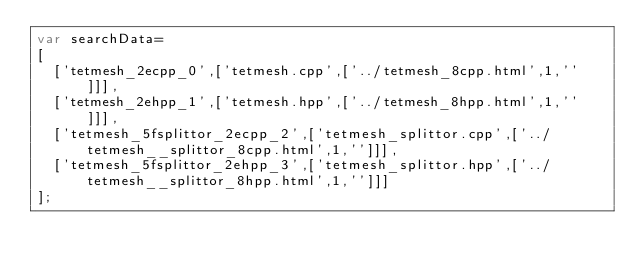Convert code to text. <code><loc_0><loc_0><loc_500><loc_500><_JavaScript_>var searchData=
[
  ['tetmesh_2ecpp_0',['tetmesh.cpp',['../tetmesh_8cpp.html',1,'']]],
  ['tetmesh_2ehpp_1',['tetmesh.hpp',['../tetmesh_8hpp.html',1,'']]],
  ['tetmesh_5fsplittor_2ecpp_2',['tetmesh_splittor.cpp',['../tetmesh__splittor_8cpp.html',1,'']]],
  ['tetmesh_5fsplittor_2ehpp_3',['tetmesh_splittor.hpp',['../tetmesh__splittor_8hpp.html',1,'']]]
];
</code> 